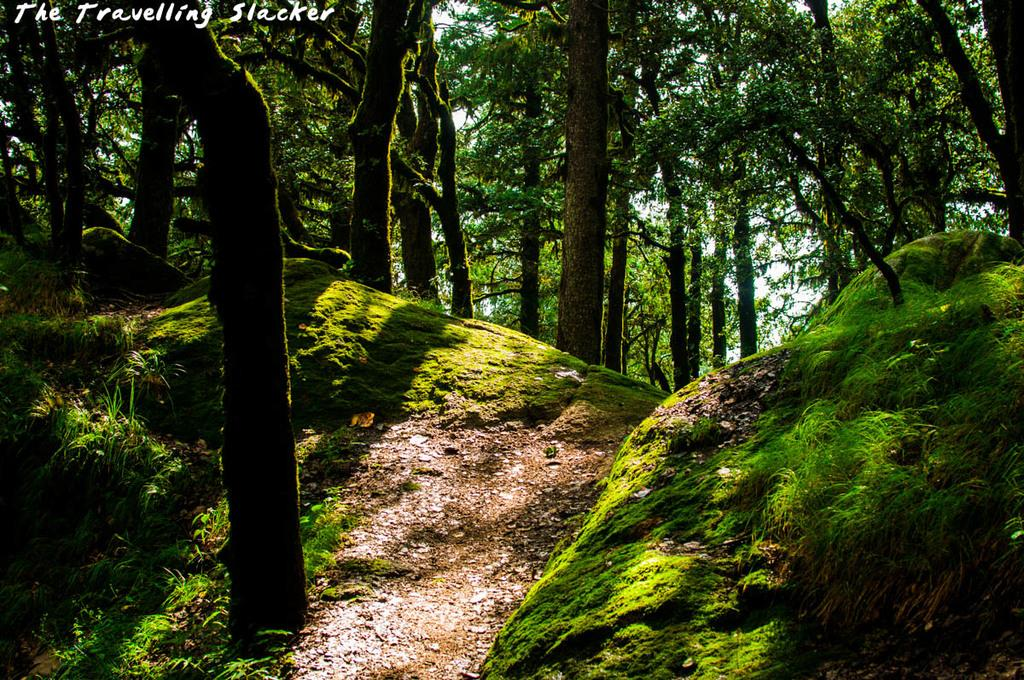What type of vegetation can be seen in the image? There are trees in the image. What is covering the ground in the image? There is grass on the ground in the image. Can you read any text in the image? Yes, there is text written at the top of the image. How many toes can be seen on the hydrant in the image? There is no hydrant present in the image, so it is not possible to determine the number of toes on it. 